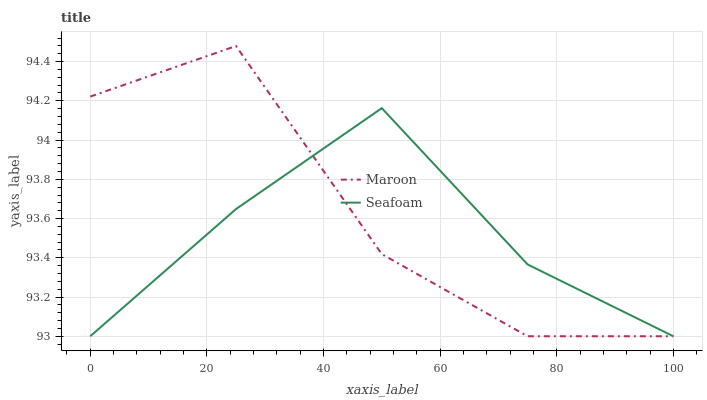Does Seafoam have the minimum area under the curve?
Answer yes or no. Yes. Does Maroon have the maximum area under the curve?
Answer yes or no. Yes. Does Maroon have the minimum area under the curve?
Answer yes or no. No. Is Seafoam the smoothest?
Answer yes or no. Yes. Is Maroon the roughest?
Answer yes or no. Yes. Is Maroon the smoothest?
Answer yes or no. No. Does Seafoam have the lowest value?
Answer yes or no. Yes. Does Maroon have the highest value?
Answer yes or no. Yes. Does Seafoam intersect Maroon?
Answer yes or no. Yes. Is Seafoam less than Maroon?
Answer yes or no. No. Is Seafoam greater than Maroon?
Answer yes or no. No. 